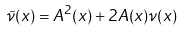<formula> <loc_0><loc_0><loc_500><loc_500>\tilde { \nu } ( x ) = A ^ { 2 } ( x ) + 2 A ( x ) \nu ( x )</formula> 